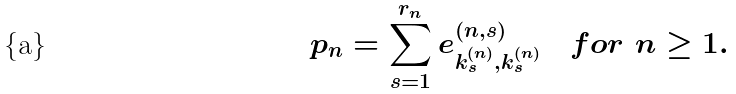<formula> <loc_0><loc_0><loc_500><loc_500>p _ { n } = \sum _ { s = 1 } ^ { r _ { n } } e _ { k _ { s } ^ { ( n ) } , k _ { s } ^ { ( n ) } } ^ { ( n , s ) } \quad { f o r } \ n \geq 1 .</formula> 